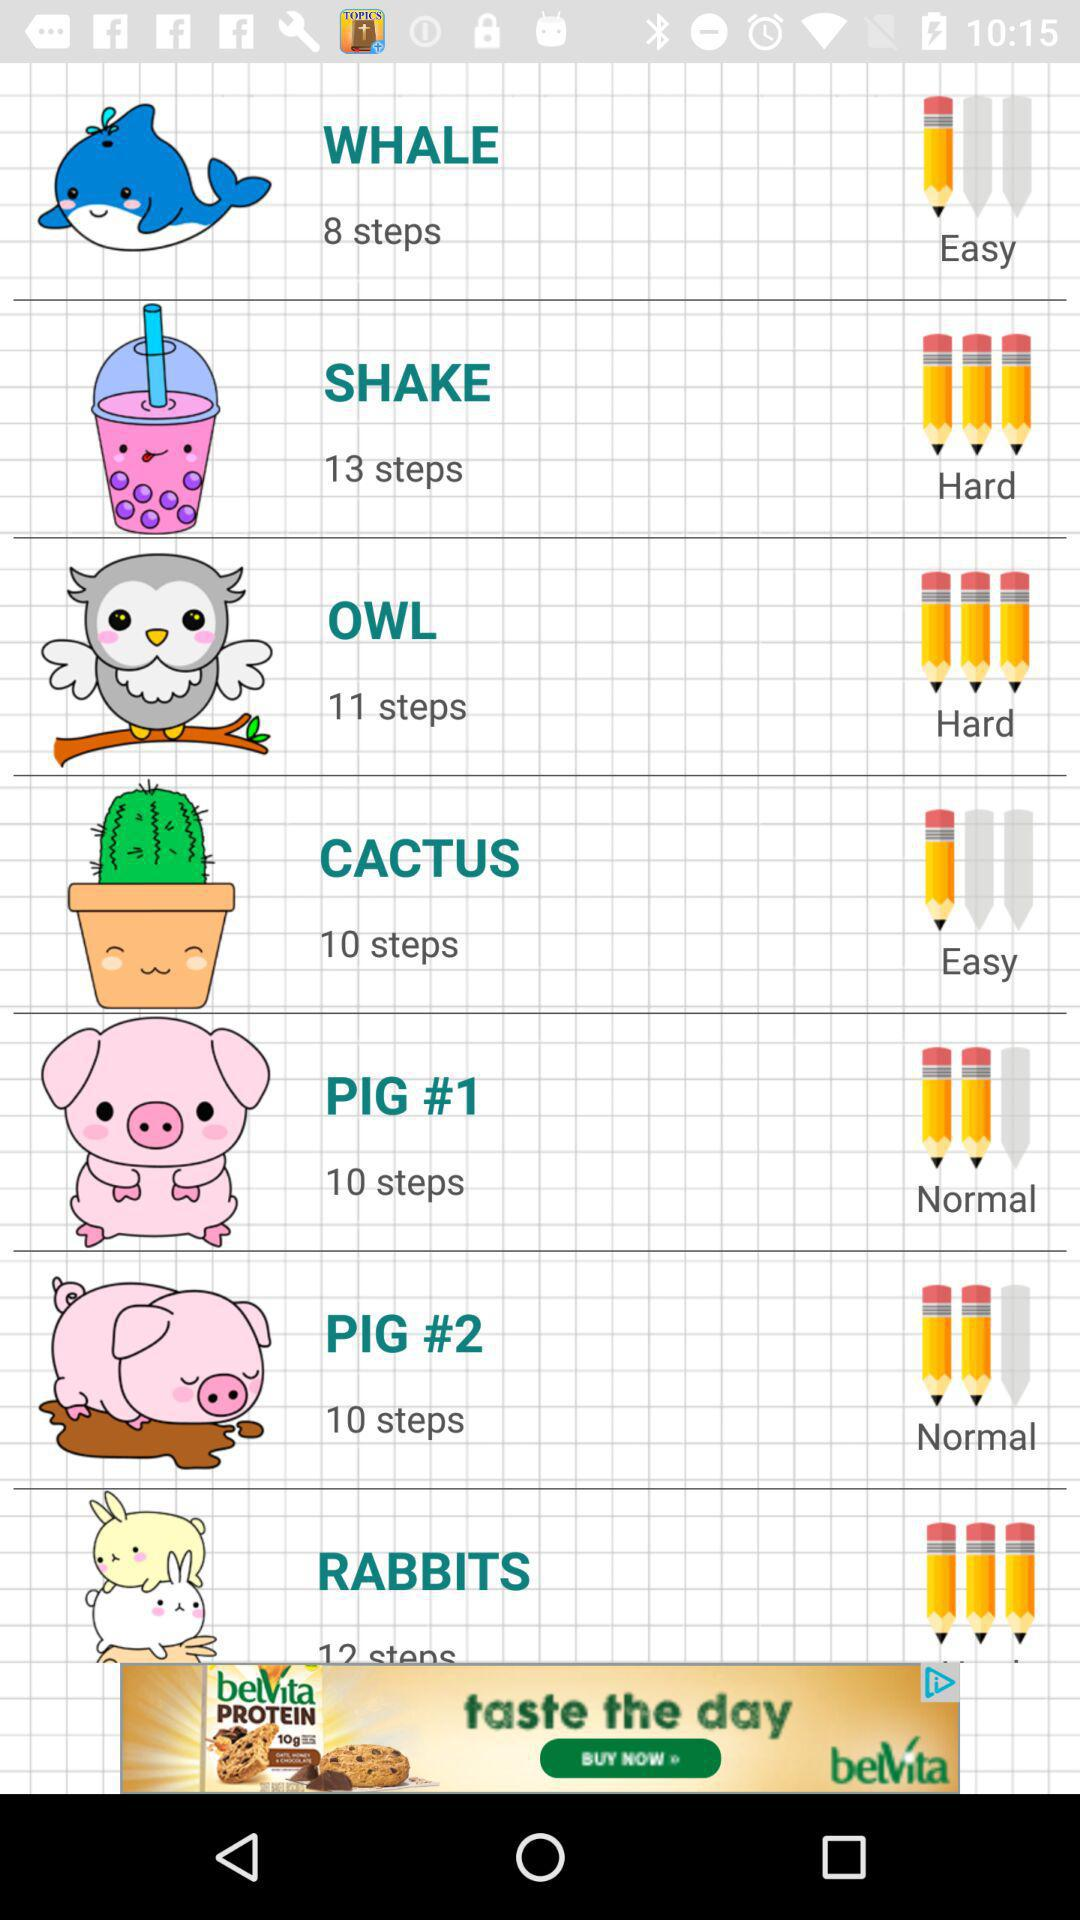Is pig easy, normal or hard?
When the provided information is insufficient, respond with <no answer>. <no answer> 